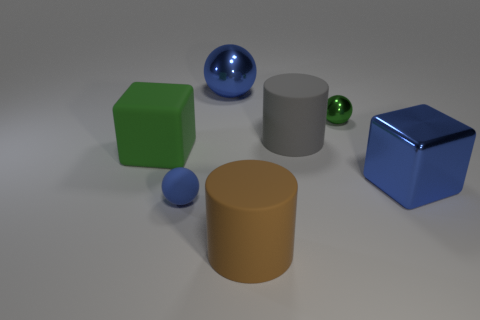What is the color of the big matte cylinder in front of the blue shiny object that is in front of the big matte object on the left side of the brown matte thing?
Ensure brevity in your answer.  Brown. There is a small object that is behind the big block that is right of the green cube; what shape is it?
Your response must be concise. Sphere. Are there more blue things that are to the left of the tiny blue matte thing than big blue shiny cylinders?
Your response must be concise. No. There is a object that is in front of the blue rubber ball; is its shape the same as the green metallic thing?
Give a very brief answer. No. Are there any other big gray objects of the same shape as the large gray object?
Provide a succinct answer. No. What number of objects are things on the left side of the big blue metallic sphere or rubber things?
Make the answer very short. 4. Is the number of big metallic cylinders greater than the number of gray rubber objects?
Make the answer very short. No. Are there any blue balls of the same size as the gray cylinder?
Make the answer very short. Yes. How many things are blue matte balls in front of the metal cube or tiny shiny objects that are behind the big shiny block?
Keep it short and to the point. 2. There is a tiny object that is to the left of the blue sphere behind the large blue block; what color is it?
Your answer should be compact. Blue. 